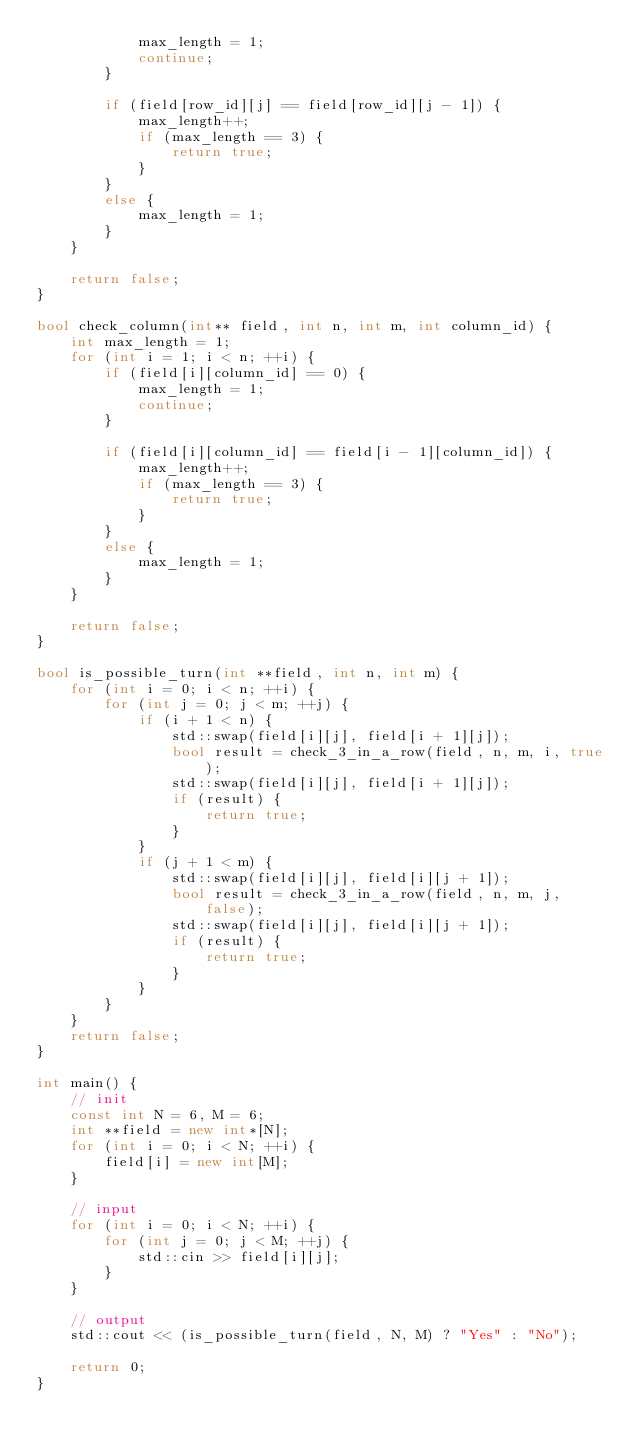<code> <loc_0><loc_0><loc_500><loc_500><_C++_>            max_length = 1;
            continue;
        }

        if (field[row_id][j] == field[row_id][j - 1]) {
            max_length++;
            if (max_length == 3) {
                return true;
            }
        }
        else {
            max_length = 1;
        }
    }

    return false;
}

bool check_column(int** field, int n, int m, int column_id) {
    int max_length = 1;
    for (int i = 1; i < n; ++i) {
        if (field[i][column_id] == 0) {
            max_length = 1;
            continue;
        }

        if (field[i][column_id] == field[i - 1][column_id]) {
            max_length++;
            if (max_length == 3) {
                return true;
            }
        }
        else {
            max_length = 1;
        }
    }

    return false;
}

bool is_possible_turn(int **field, int n, int m) {
    for (int i = 0; i < n; ++i) {
        for (int j = 0; j < m; ++j) {
            if (i + 1 < n) {
                std::swap(field[i][j], field[i + 1][j]);
                bool result = check_3_in_a_row(field, n, m, i, true);
                std::swap(field[i][j], field[i + 1][j]);
                if (result) {
                    return true;
                }
            }
            if (j + 1 < m) {
                std::swap(field[i][j], field[i][j + 1]);
                bool result = check_3_in_a_row(field, n, m, j, false);
                std::swap(field[i][j], field[i][j + 1]);
                if (result) {
                    return true;
                }
            }
        }
    }
    return false;
}

int main() {
    // init
    const int N = 6, M = 6;
    int **field = new int*[N];
    for (int i = 0; i < N; ++i) {
        field[i] = new int[M];
    }

    // input
    for (int i = 0; i < N; ++i) {
        for (int j = 0; j < M; ++j) {
            std::cin >> field[i][j];
        }
    }
    
    // output
    std::cout << (is_possible_turn(field, N, M) ? "Yes" : "No");

    return 0;
}</code> 